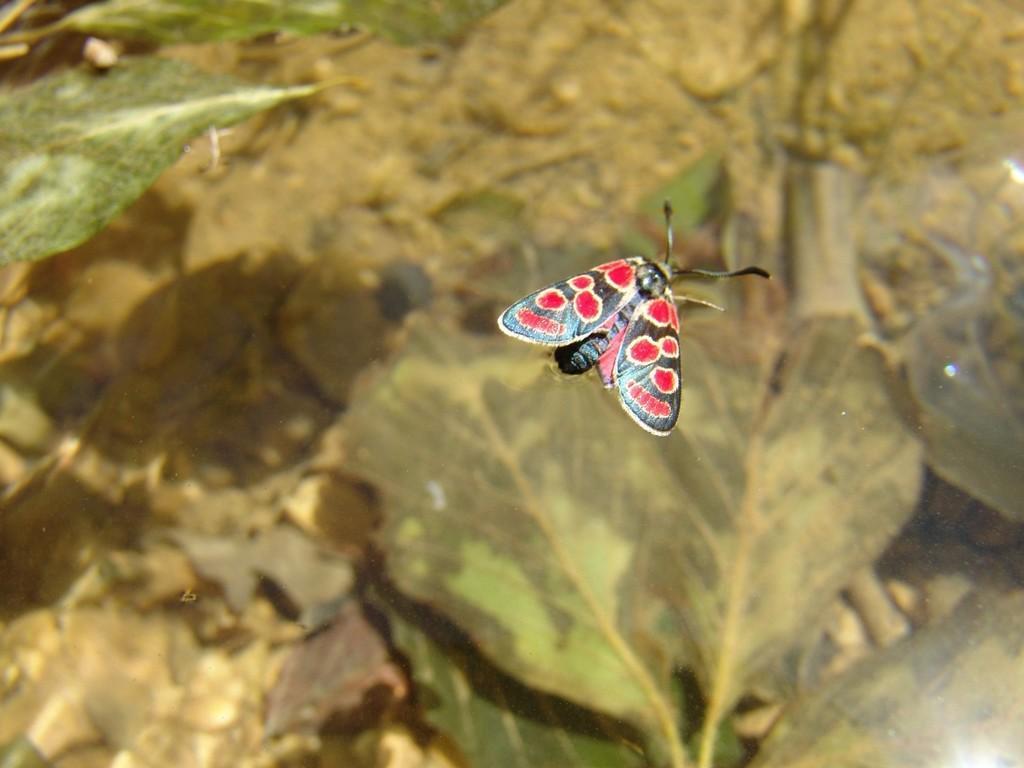In one or two sentences, can you explain what this image depicts? In this image in the front there is a butterfly. In the background there are leaves. 